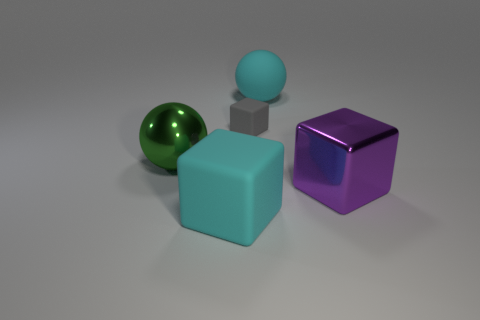Are these objects placed in any particular arrangement? The objects are spaced out on a flat surface, not arranged in any specific pattern. They seem randomly placed, with the larger blue cube to the left, the green sphere in front, the small gray cube in the middle, and the reflective purple cube to the right. 